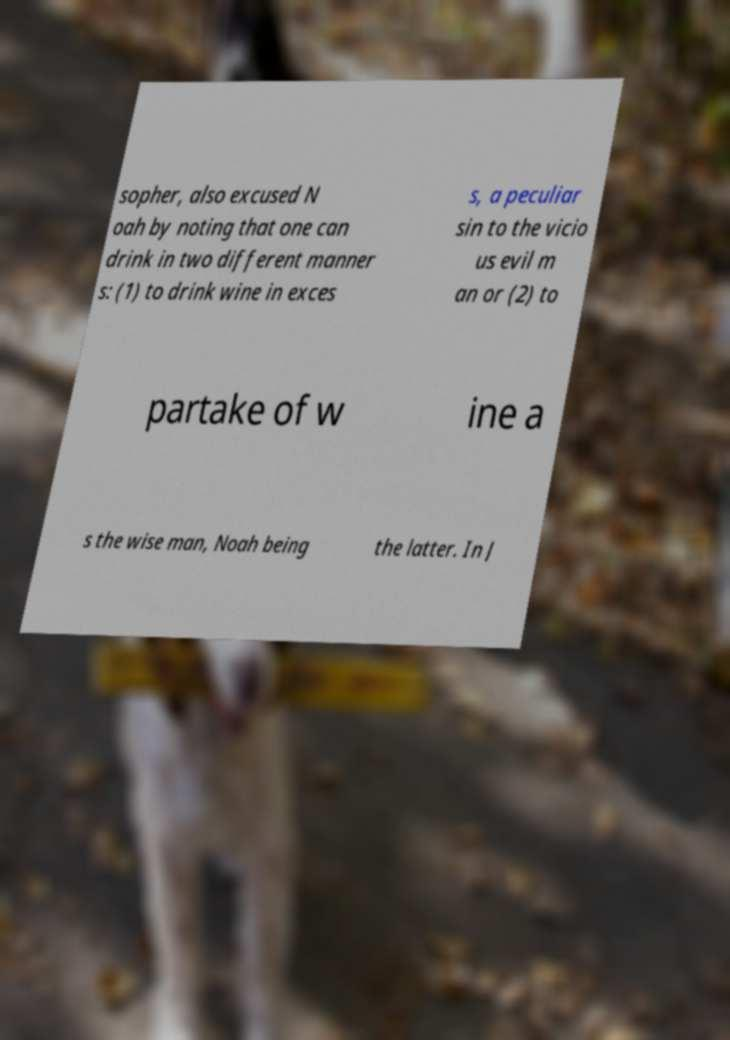Could you assist in decoding the text presented in this image and type it out clearly? sopher, also excused N oah by noting that one can drink in two different manner s: (1) to drink wine in exces s, a peculiar sin to the vicio us evil m an or (2) to partake of w ine a s the wise man, Noah being the latter. In J 